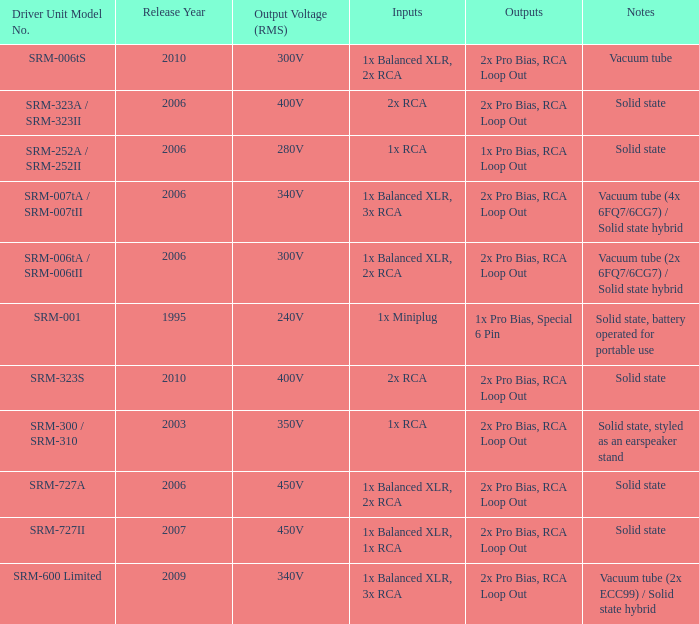How many outputs are there for solid state, battery operated for portable use listed in notes? 1.0. 